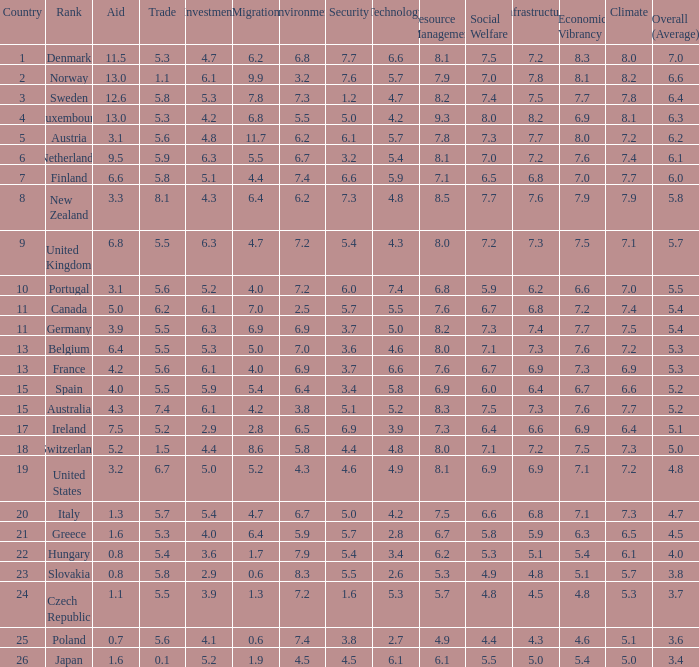What is the migration rating when trade is 5.7? 4.7. 